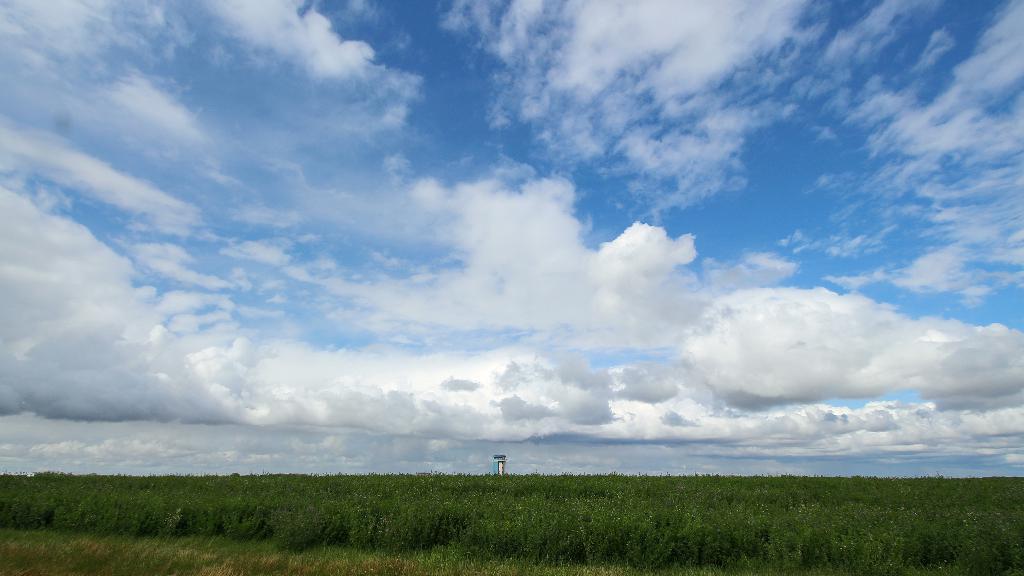Please provide a concise description of this image. In this image we can see the green fields on the ground, one object in the middle of the image and there is the cloudy sky in the background. 